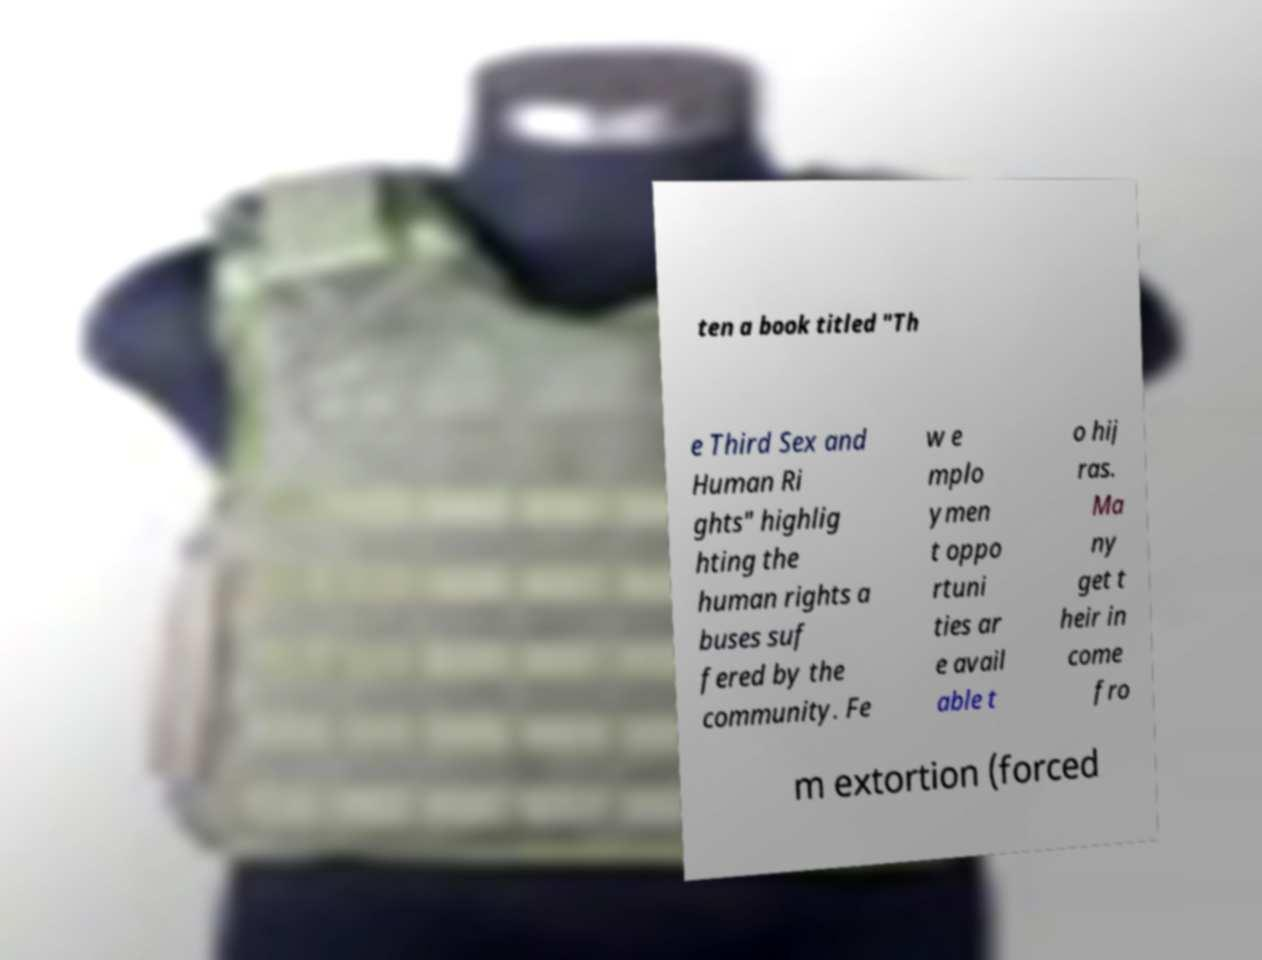For documentation purposes, I need the text within this image transcribed. Could you provide that? ten a book titled "Th e Third Sex and Human Ri ghts" highlig hting the human rights a buses suf fered by the community. Fe w e mplo ymen t oppo rtuni ties ar e avail able t o hij ras. Ma ny get t heir in come fro m extortion (forced 